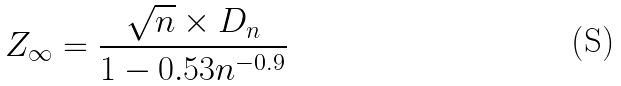Convert formula to latex. <formula><loc_0><loc_0><loc_500><loc_500>Z _ { \infty } = \frac { \sqrt { n } \times D _ { n } } { 1 - 0 . 5 3 n ^ { - 0 . 9 } }</formula> 